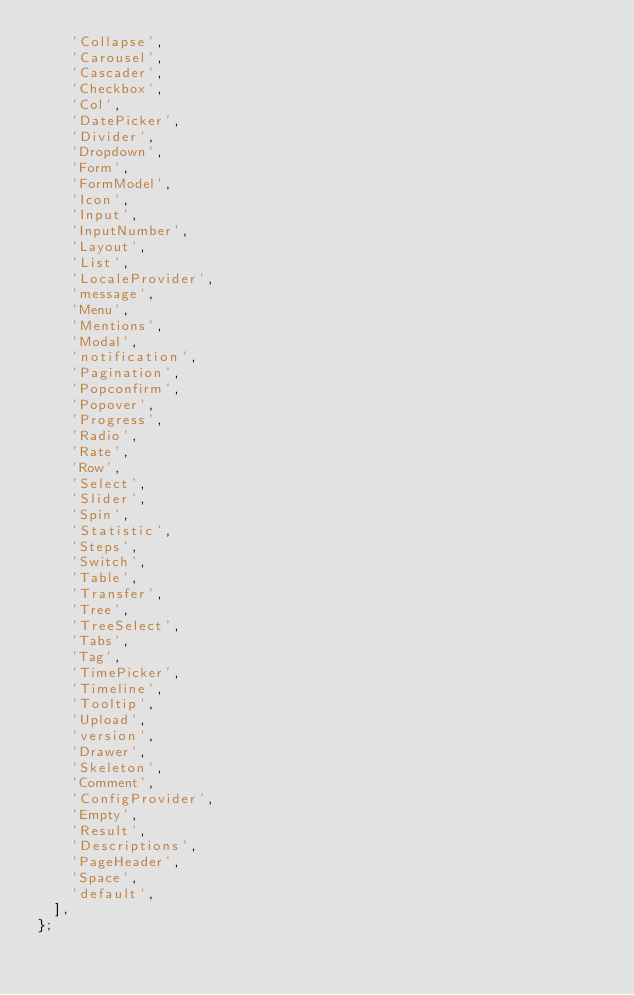<code> <loc_0><loc_0><loc_500><loc_500><_JavaScript_>    'Collapse',
    'Carousel',
    'Cascader',
    'Checkbox',
    'Col',
    'DatePicker',
    'Divider',
    'Dropdown',
    'Form',
    'FormModel',
    'Icon',
    'Input',
    'InputNumber',
    'Layout',
    'List',
    'LocaleProvider',
    'message',
    'Menu',
    'Mentions',
    'Modal',
    'notification',
    'Pagination',
    'Popconfirm',
    'Popover',
    'Progress',
    'Radio',
    'Rate',
    'Row',
    'Select',
    'Slider',
    'Spin',
    'Statistic',
    'Steps',
    'Switch',
    'Table',
    'Transfer',
    'Tree',
    'TreeSelect',
    'Tabs',
    'Tag',
    'TimePicker',
    'Timeline',
    'Tooltip',
    'Upload',
    'version',
    'Drawer',
    'Skeleton',
    'Comment',
    'ConfigProvider',
    'Empty',
    'Result',
    'Descriptions',
    'PageHeader',
    'Space',
    'default',
  ],
};</code> 